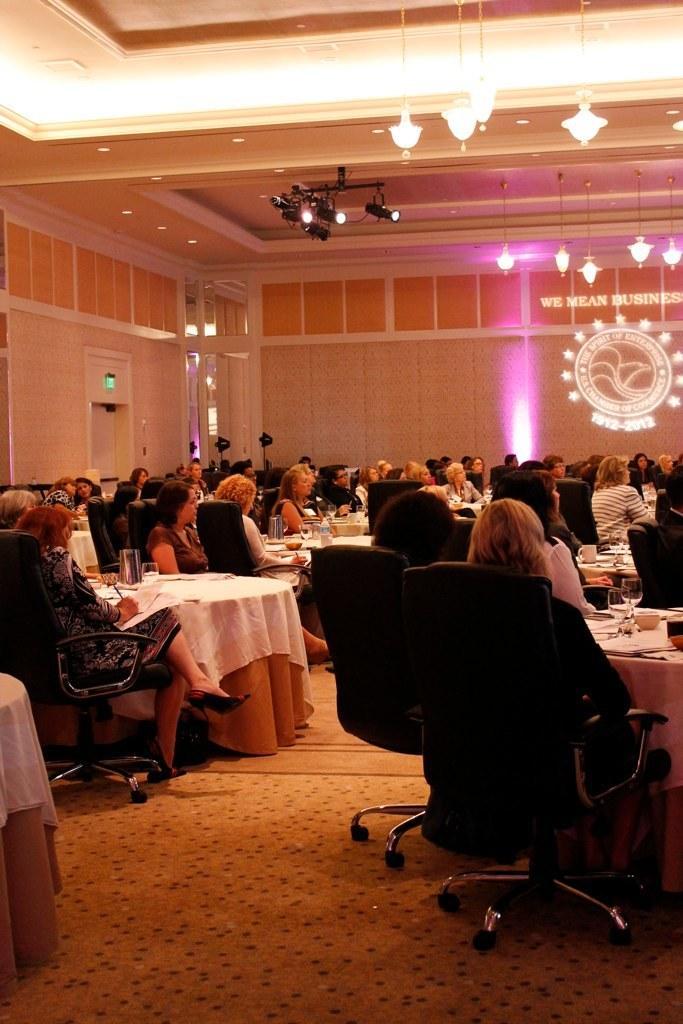Can you describe this image briefly? In this image there are group of people sitting in chair near the table ,and in table there are glass , paper and the back ground there is chandeliers , focus lights , door. 